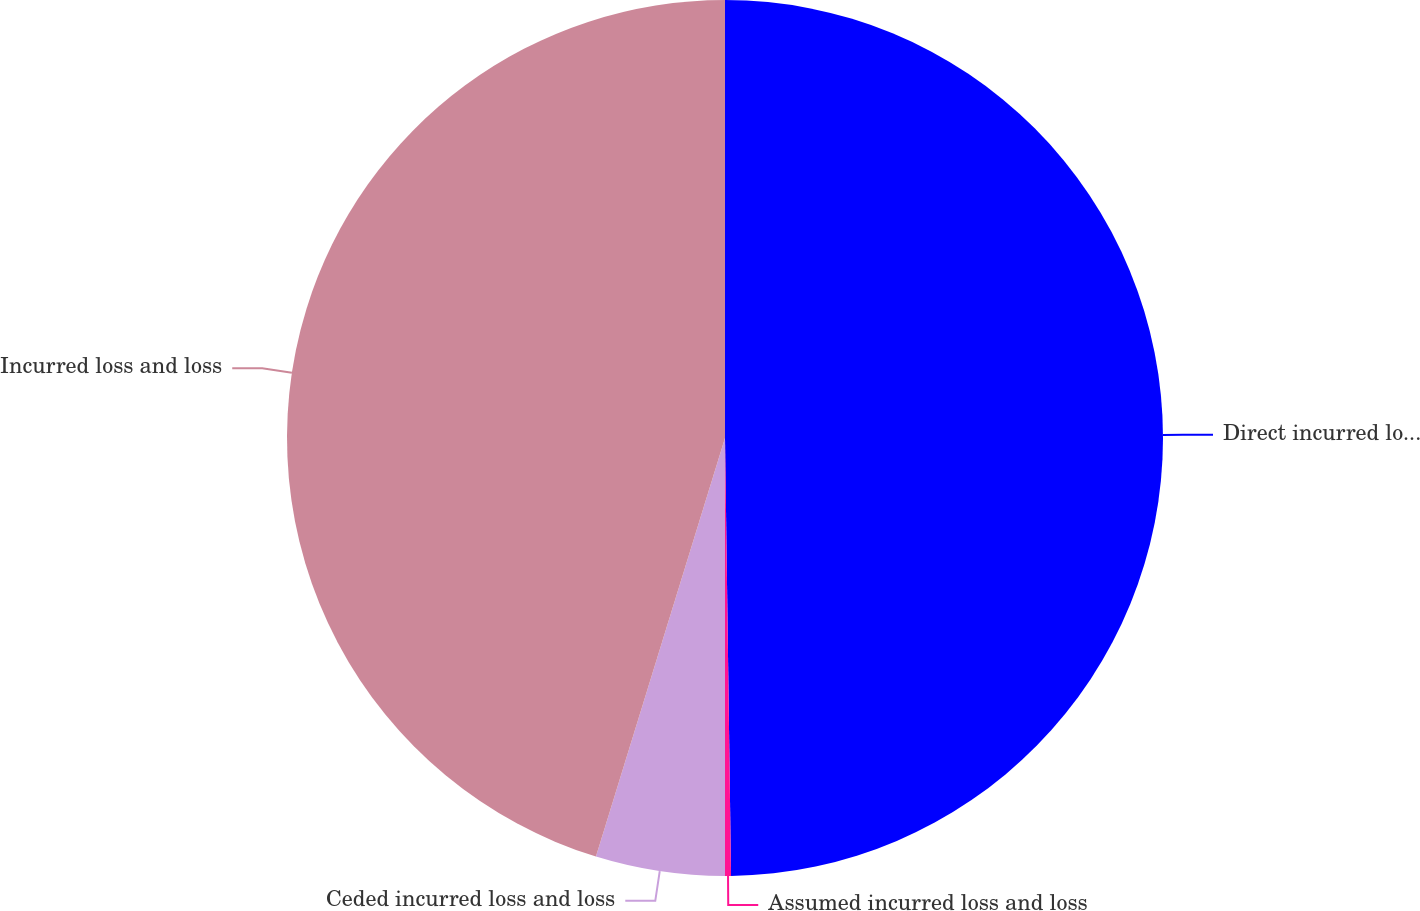<chart> <loc_0><loc_0><loc_500><loc_500><pie_chart><fcel>Direct incurred loss and loss<fcel>Assumed incurred loss and loss<fcel>Ceded incurred loss and loss<fcel>Incurred loss and loss<nl><fcel>49.78%<fcel>0.22%<fcel>4.76%<fcel>45.24%<nl></chart> 